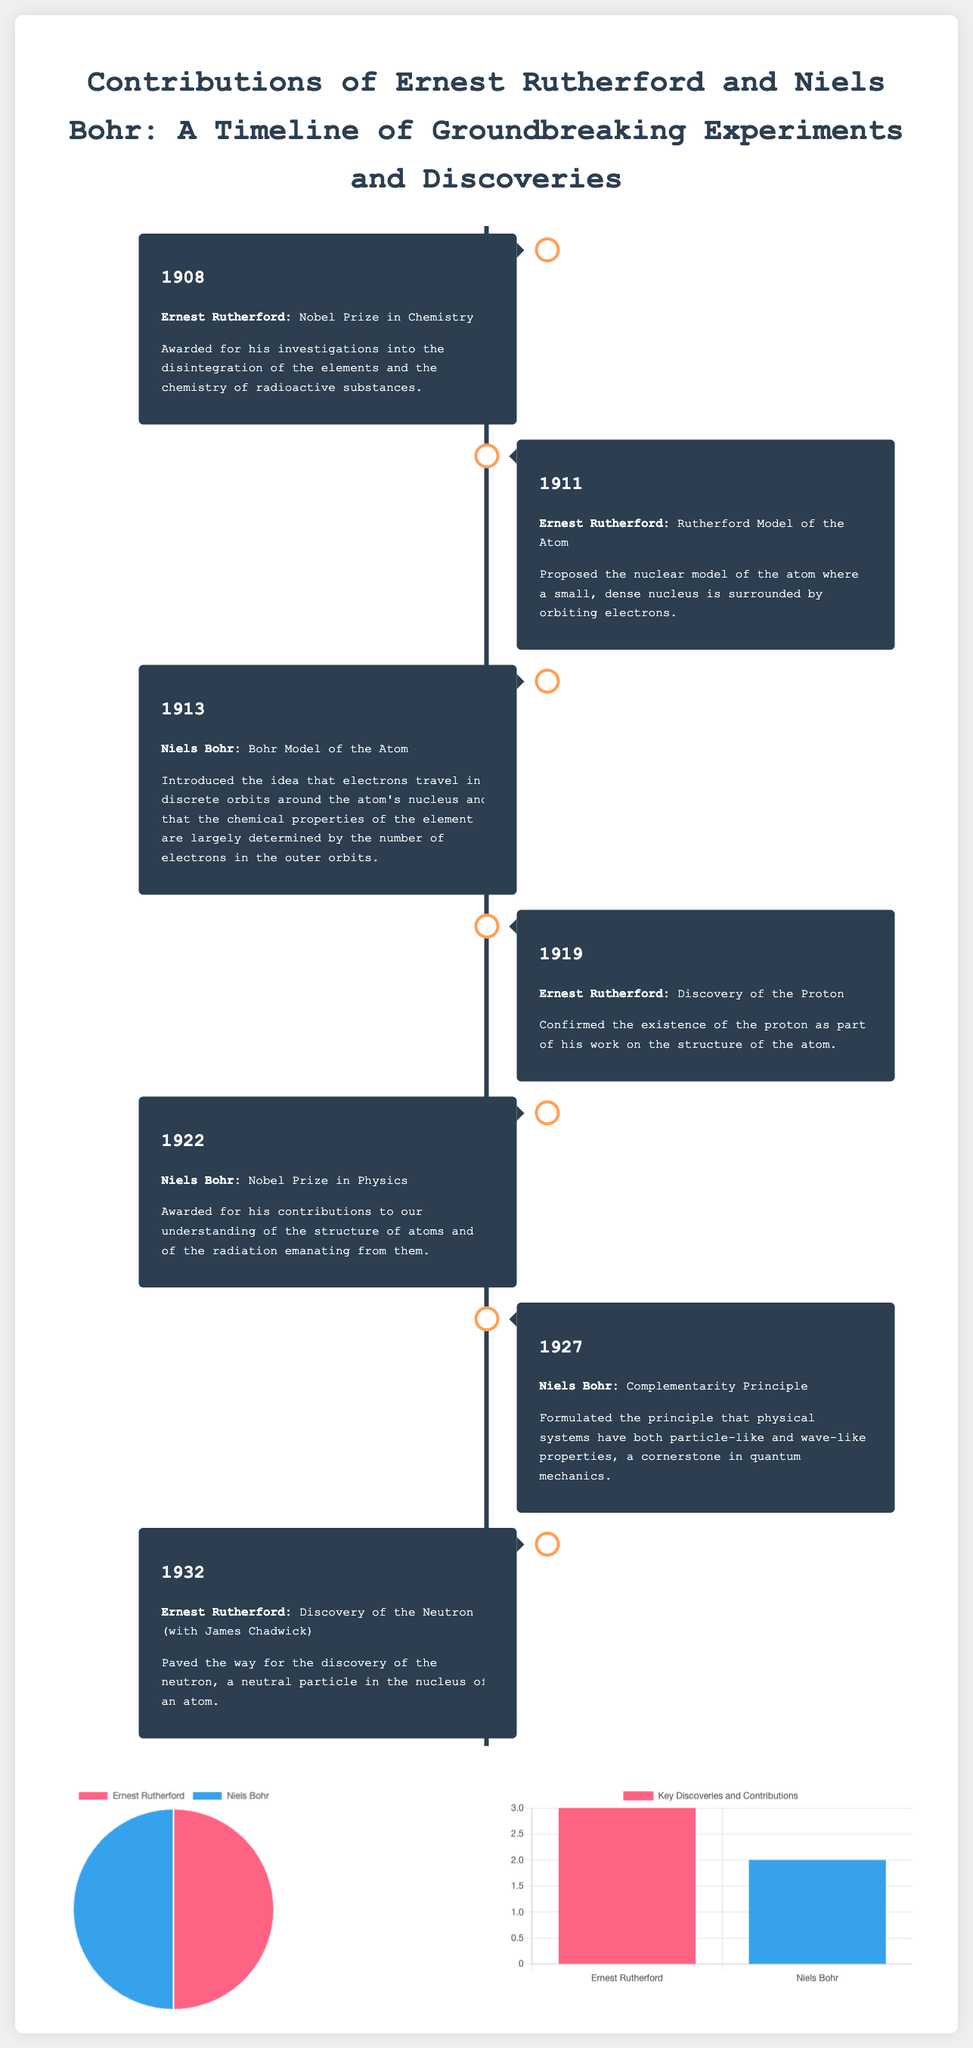What year did Ernest Rutherford win the Nobel Prize? The document states that Rutherford was awarded the Nobel Prize in Chemistry in 1908.
Answer: 1908 What atomic model did Niels Bohr propose? According to the timeline, Niels Bohr introduced the Bohr Model of the Atom in 1913.
Answer: Bohr Model of the Atom How many Nobel Prizes did Niels Bohr win? The infographic indicates that Niels Bohr won 1 Nobel Prize, as shown in the Nobel Prize chart.
Answer: 1 In what year was the proton discovered by Rutherford? The document mentions that Rutherford confirmed the existence of the proton in 1919.
Answer: 1919 Which principle did Niels Bohr formulate in 1927? The timeline details that Bohr formulated the Complementarity Principle in 1927.
Answer: Complementarity Principle How many key discoveries and contributions are attributed to Ernest Rutherford? The bar chart shows that Rutherford is credited with 3 key discoveries and contributions.
Answer: 3 Which year did Rutherford discover the neutron with James Chadwick? The timeline indicates that the neutron was discovered in 1932.
Answer: 1932 What color represents Niels Bohr in the charts? The document specifies that the color representing Bohr in the charts is blue.
Answer: Blue 